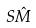Convert formula to latex. <formula><loc_0><loc_0><loc_500><loc_500>S \hat { M }</formula> 